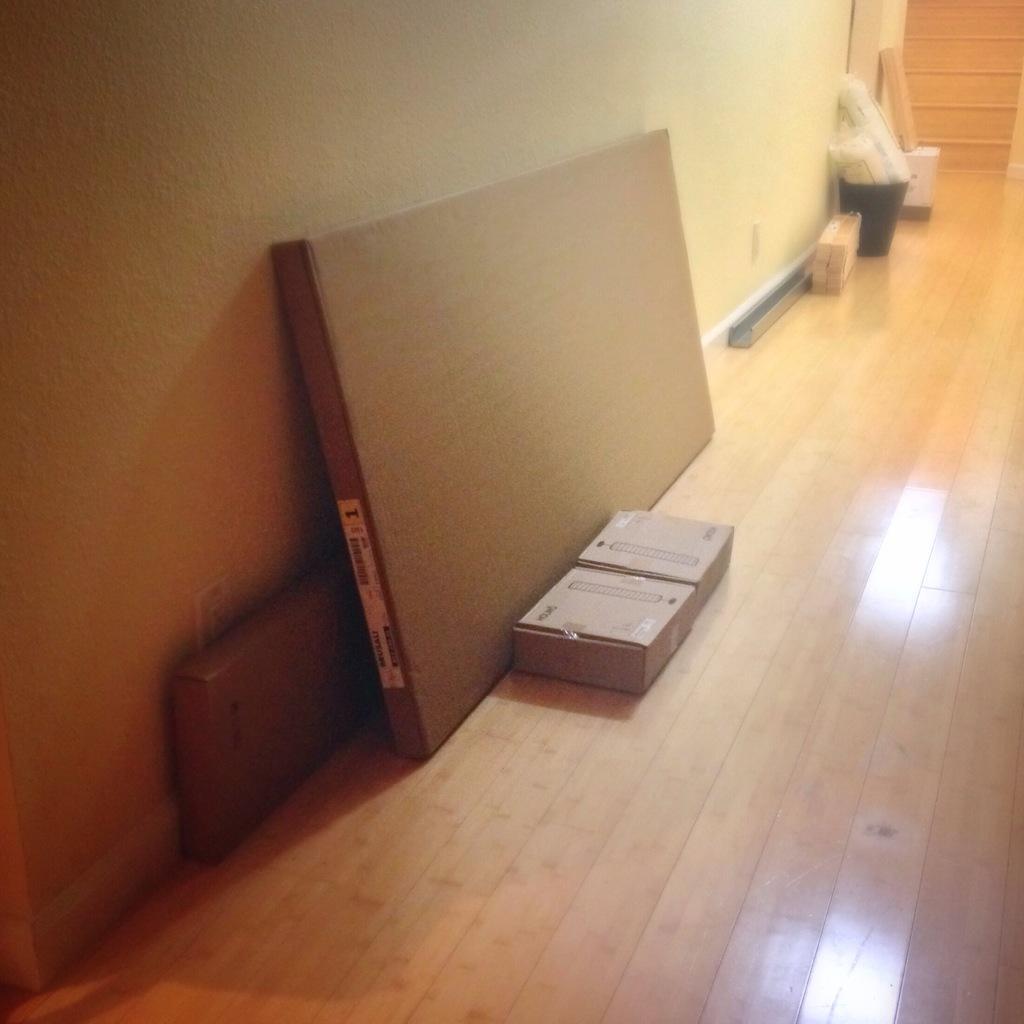In one or two sentences, can you explain what this image depicts? In this picture we can see there are cardboard boxes and some objects on the wooden floor. On the left side of the image there is a wall. At the top right corner of the image, it looks like a staircase. 